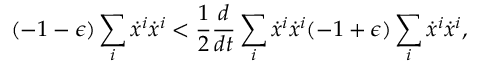<formula> <loc_0><loc_0><loc_500><loc_500>( - 1 - \epsilon ) \sum _ { i } \dot { x } ^ { i } \dot { x } ^ { i } < \frac { 1 } { 2 } \frac { d } { d t } \sum _ { i } \dot { x } ^ { i } \dot { x } ^ { i } ( - 1 + \epsilon ) \sum _ { i } \dot { x } ^ { i } \dot { x } ^ { i } ,</formula> 